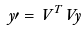<formula> <loc_0><loc_0><loc_500><loc_500>y \prime = V ^ { T } V y</formula> 